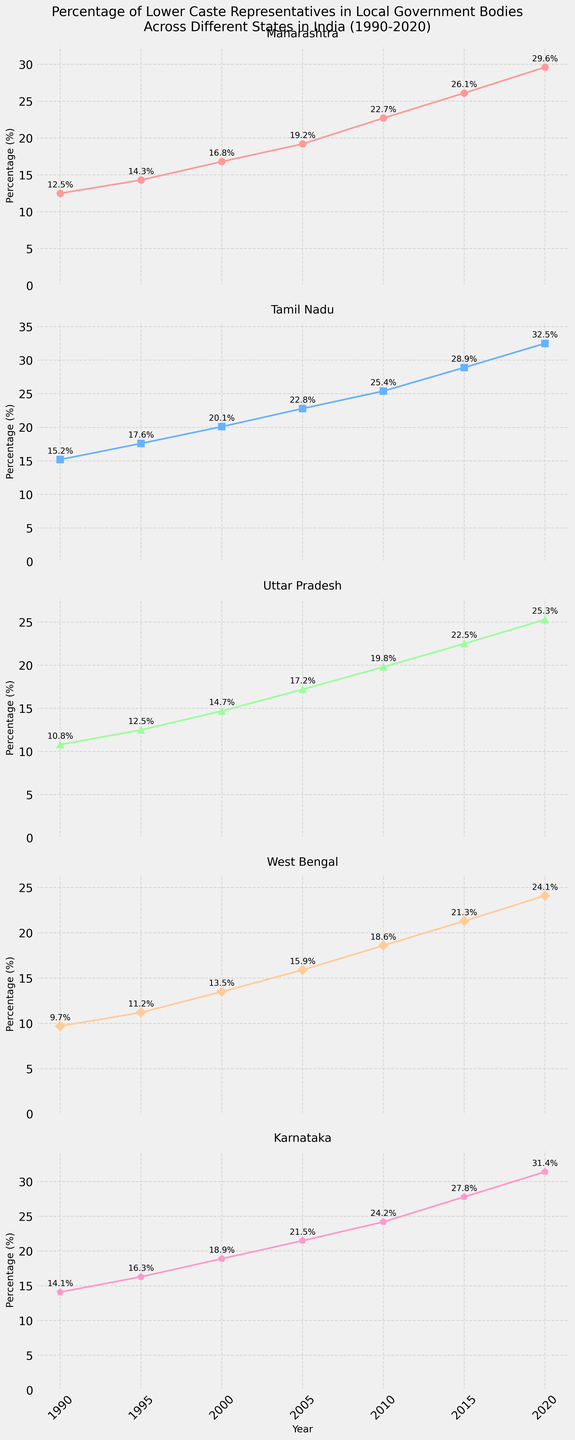What was the percentage of lower caste representatives in Maharashtra in 2000 and 2020? The plot for Maharashtra shows data points marked at specific years. For 2000, the value is annotated as 16.8%, and for 2020, it is 29.6%.
Answer: 16.8% in 2000, 29.6% in 2020 How does the increase in percentage of lower caste representatives in Tamil Nadu from 1990 to 2020 compare with Karnataka? To determine the increase, subtract the initial value in 1990 from the final value in 2020 for both states. For Tamil Nadu: 32.5% - 15.2% = 17.3%; for Karnataka: 31.4% - 14.1% = 17.3%. Therefore, the increase is the same for both states.
Answer: Both increased by 17.3% Which state had the lowest percentage of lower caste representatives in 1990 and in 2020? Checking the plots for each state in 1990, West Bengal had the lowest value at 9.7%. In 2020, West Bengal still had the lowest value at 24.1%.
Answer: West Bengal in both 1990 and 2020 What is the average percentage of lower caste representatives in Uttar Pradesh across all years shown? The values for each year are 10.8%, 12.5%, 14.7%, 17.2%, 19.8%, 22.5%, 25.3%. Add them: 10.8 + 12.5 + 14.7 + 17.2 + 19.8 + 22.5 + 25.3 = 122.8. Then divide by the number of years (7): 122.8/7 = 17.54%.
Answer: 17.54% In which year did West Bengal first surpass 20% representation? By checking the plot for West Bengal, it shows that the percentage reaches 21.3% in 2015. Hence, this is the first year surpassing 20%.
Answer: 2015 Which state shows the steepest growth in lower caste representation between 1990 and 2020? To determine steep growth, compare the slope (change) of the values from 1990 to 2020 for each state. Tamil Nadu increased from 15.2% to 32.5%, which is a change of 17.3%, the largest among the states.
Answer: Tamil Nadu How does the 2010 percentage in Karnataka compare to Maharashtra? From the data points annotated for 2010, Karnataka stands at 24.2% and Maharashtra at 22.7%. Hence, Karnataka's percentage is higher.
Answer: Karnataka is higher in 2010 Which state had the most consistent increase in lower caste representatives' percentage over the years? Consistency can be judged by observing relatively uniform increments across all years. Tamil Nadu shows a relatively linear and steady increase from 15.2% in 1990 to 32.5% in 2020.
Answer: Tamil Nadu What's the difference in the percentage of lower caste representatives in Maharashtra between 1995 and 2015? The values are 14.3% in 1995 and 26.1% in 2015. Subtracting the 1995 value from the 2015 value gives: 26.1% - 14.3% = 11.8%.
Answer: 11.8% Which color represents Maharashtra in the plot and what implication does this have for discerning trends? The subplot for Maharashtra is shown with a pinkish-red color. This distinct color helps to clearly distinguish its trends and values in the plot.
Answer: Pinkish-red 